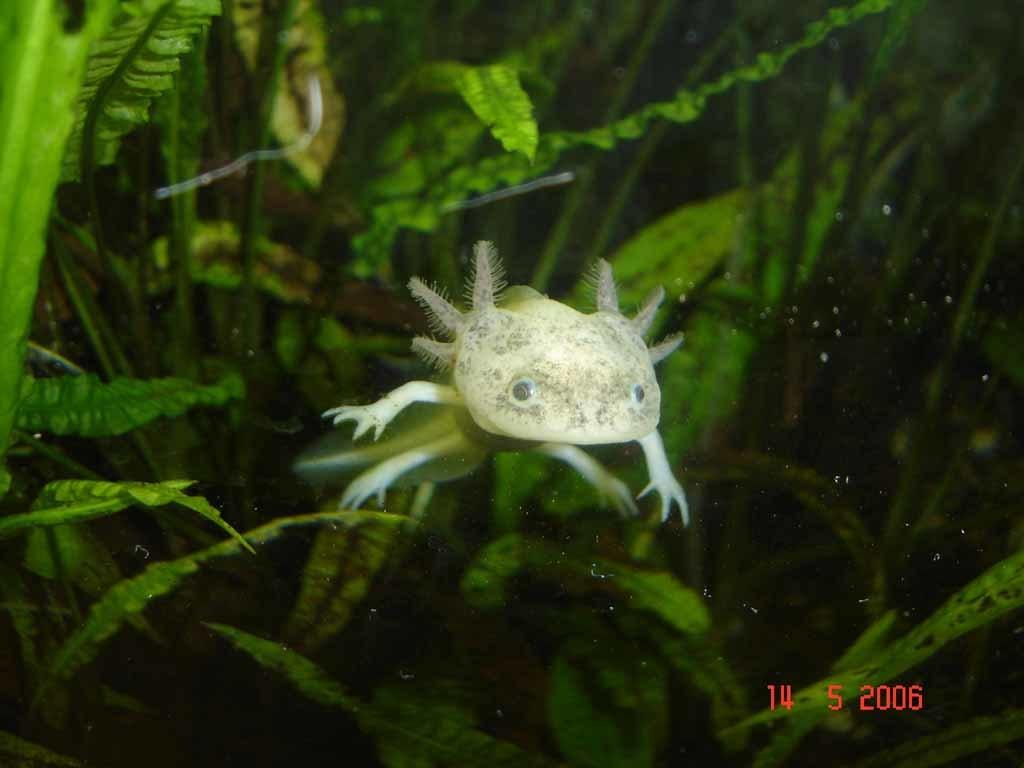What type of living creature is in the image? There is an animal in the image. What can be seen in the background of the image? There are plants in the background of the image. What color are the plants in the image? The plants are green in color. How many crayons are being used by the animal in the image? There are no crayons present in the image, and the animal is not using any. 